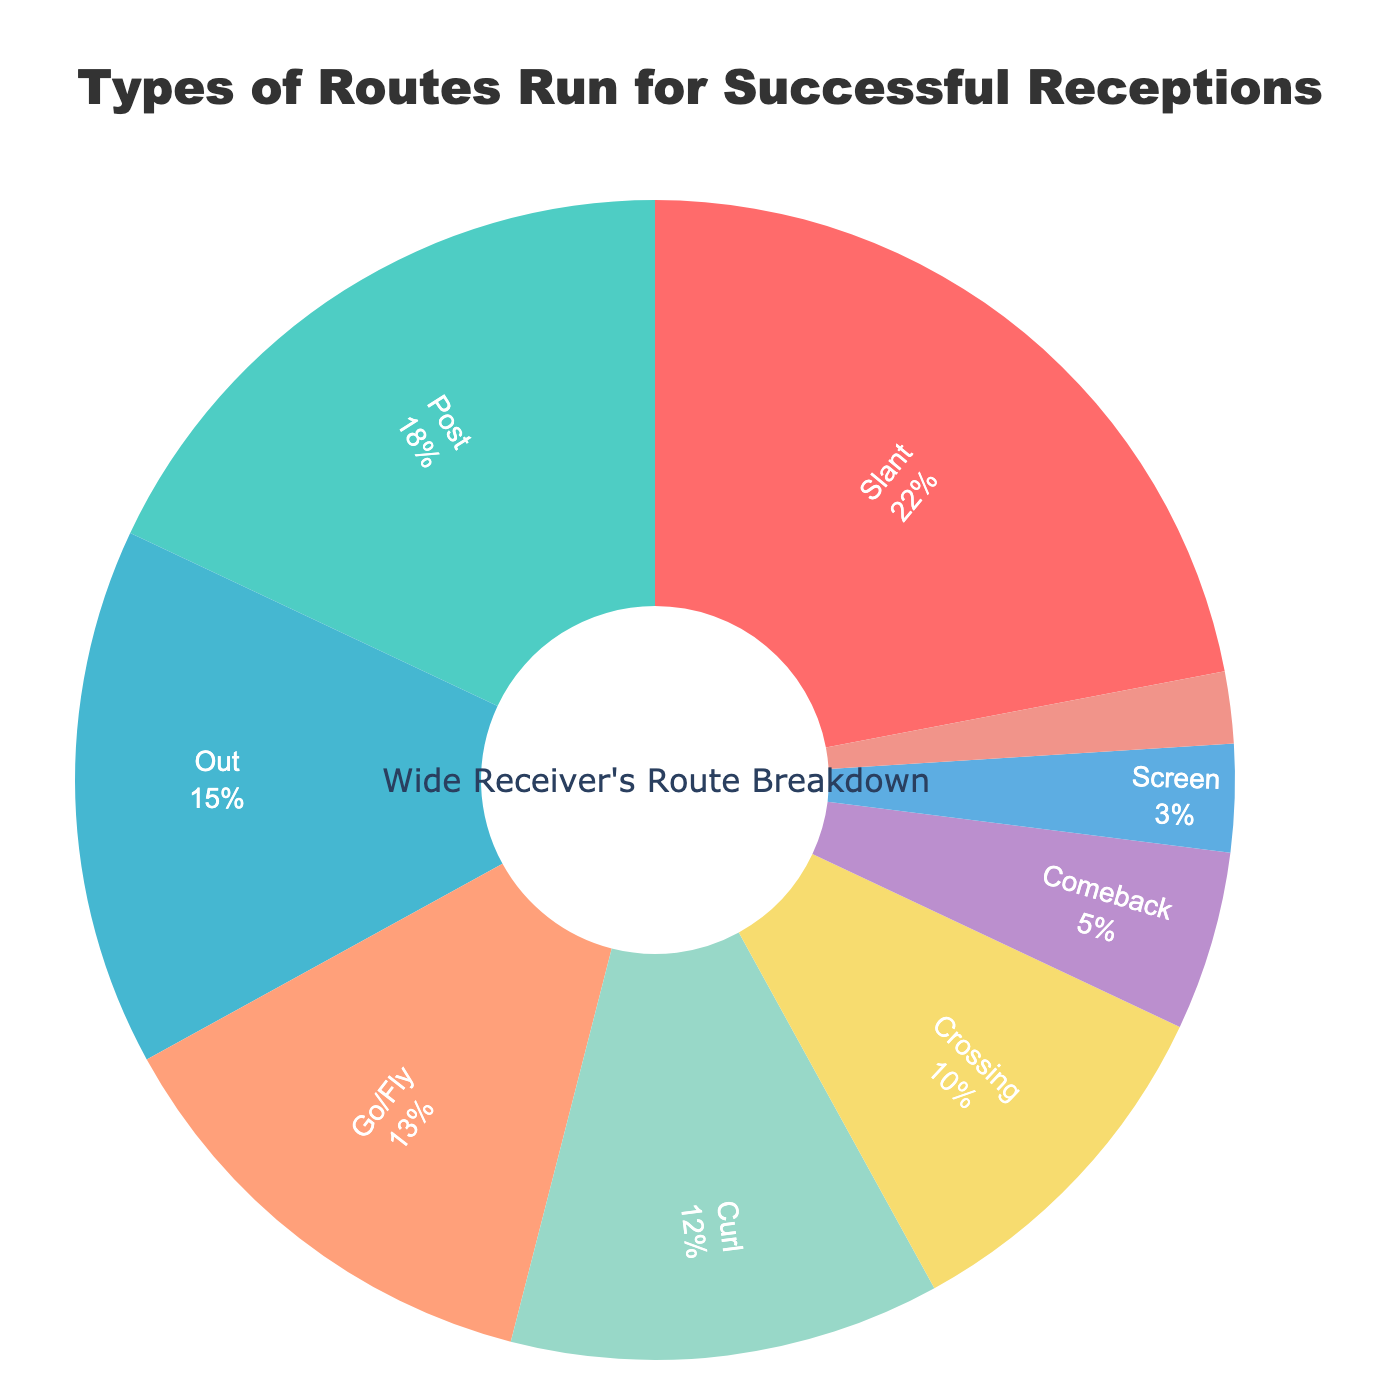What is the title of the pie chart? The title is positioned at the top of the chart and reads, "Types of Routes Run for Successful Receptions."
Answer: Types of Routes Run for Successful Receptions What percentage of successful receptions were made using slant routes? The segment for slant routes indicates a percentage value.
Answer: 22% Which route type has the smallest percentage of successful receptions? The segment representing the smallest percentage slice shows the label "Wheel" alongside its percentage value.
Answer: Wheel How many route types contribute to successful receptions, according to the chart? Each segment represents a unique route type, and counting all segments gives the total number.
Answer: 9 Which has a higher percentage: Out routes or Go/Fly routes? Compare the percentage values noted for Out routes (15%) and Go/Fly routes (13%).
Answer: Out routes What is the combined percentage of slant and post routes? Adding the percentages for slant (22%) and post routes (18%): 22 + 18 = 40.
Answer: 40% If you combine the percentages for screen and wheel routes, is it higher or lower than comeback routes? Adding the percentages for screen (3%) and wheel (2%) gives 5%. Compare this to the percentage for comeback routes (5%).
Answer: Equal Which route types contribute to at least 15% of successful receptions each? Identify the segments with percentages 15% or higher: Slant (22%), Post (18%), and Out (15%).
Answer: Slant, Post, Out How does the percentage of curl routes compare to crossing routes? Compare the percentage values noted for curl routes (12%) and crossing routes (10%).
Answer: Curl routes have a higher percentage What percentage of total successful receptions is represented by routes other than slant, post, and out? Sum the percentages of all routes then subtract the total for slant, post, and out. Total = 100. Slant + Post + Out = 22 + 18 + 15 = 55. 100 - 55 = 45
Answer: 45% 